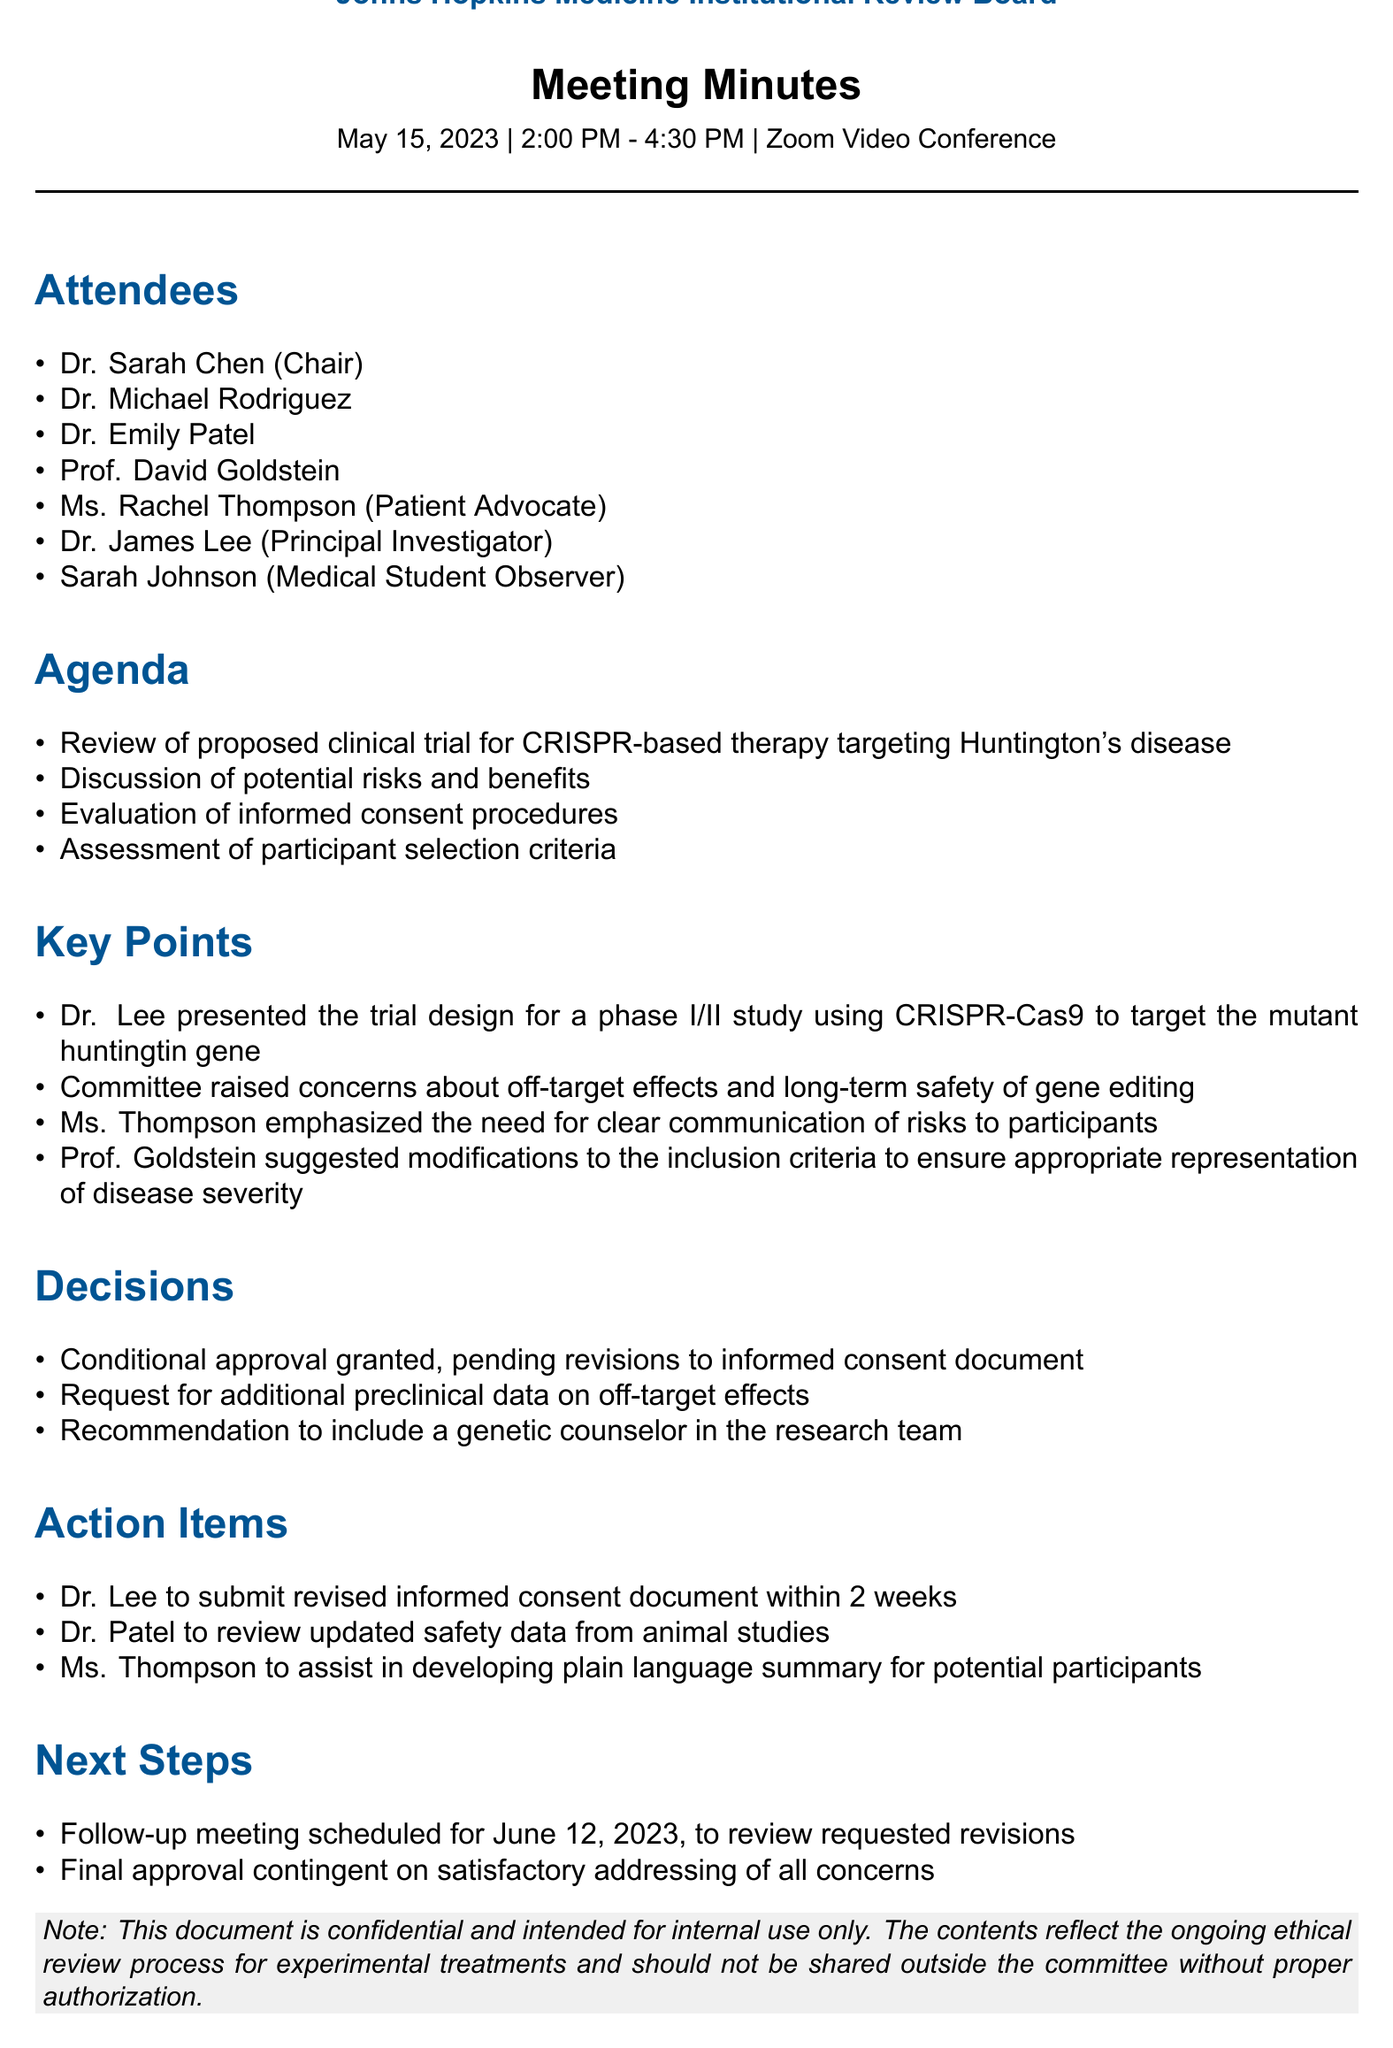what is the name of the committee conducting the review? The name of the committee is mentioned at the beginning of the document.
Answer: Johns Hopkins Medicine Institutional Review Board who presented the trial design? The document states who presented during the meeting.
Answer: Dr. James Lee what is the date of the follow-up meeting? The date of the follow-up meeting is specified in the next steps section of the document.
Answer: June 12, 2023 how long is the follow-up period for the informed consent document revisions? The action items outline the timeline for submission related to informed consent.
Answer: 2 weeks what approval was granted conditionally? The decisions section lists the conditional approvals granted during the meeting.
Answer: informed consent document what concern did the committee raise regarding the gene editing? A concern raised during the meeting is explicitly mentioned in the key points section.
Answer: off-target effects who is responsible for reviewing updated safety data? The action items specify who will handle this particular task.
Answer: Dr. Patel who emphasized the need for clear communication of risks? The key points section indicates who made this emphasis during the meeting.
Answer: Ms. Rachel Thompson 